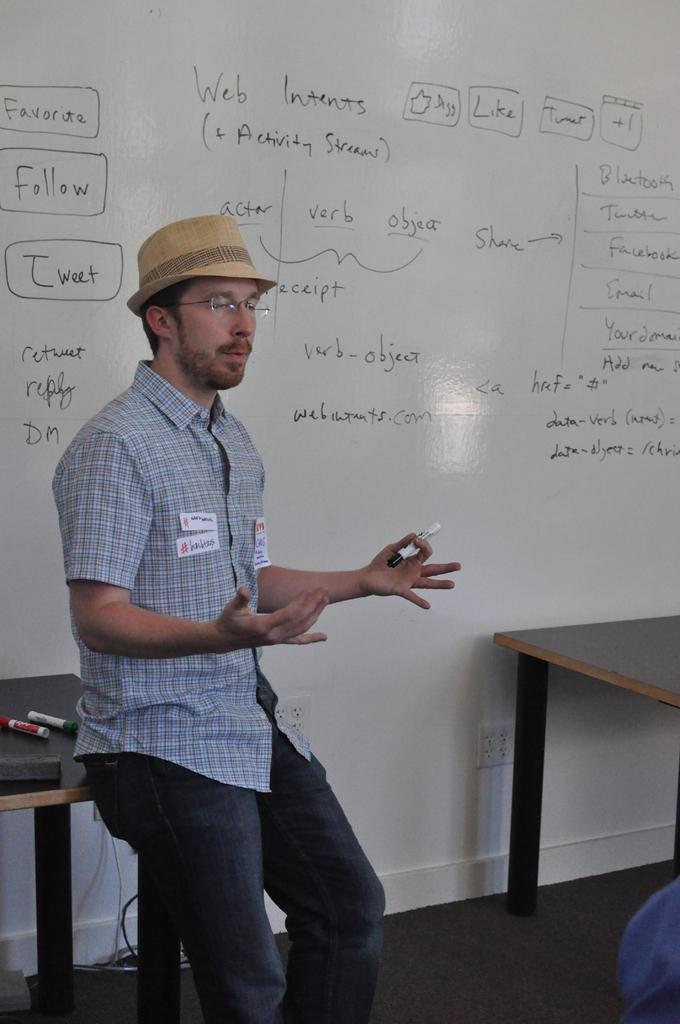<image>
Give a short and clear explanation of the subsequent image. A man in a hat is standing in front of a very large dry erase board that includes words in boxes like "favorite", "follow", "tweet". 